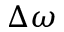Convert formula to latex. <formula><loc_0><loc_0><loc_500><loc_500>\Delta \omega</formula> 